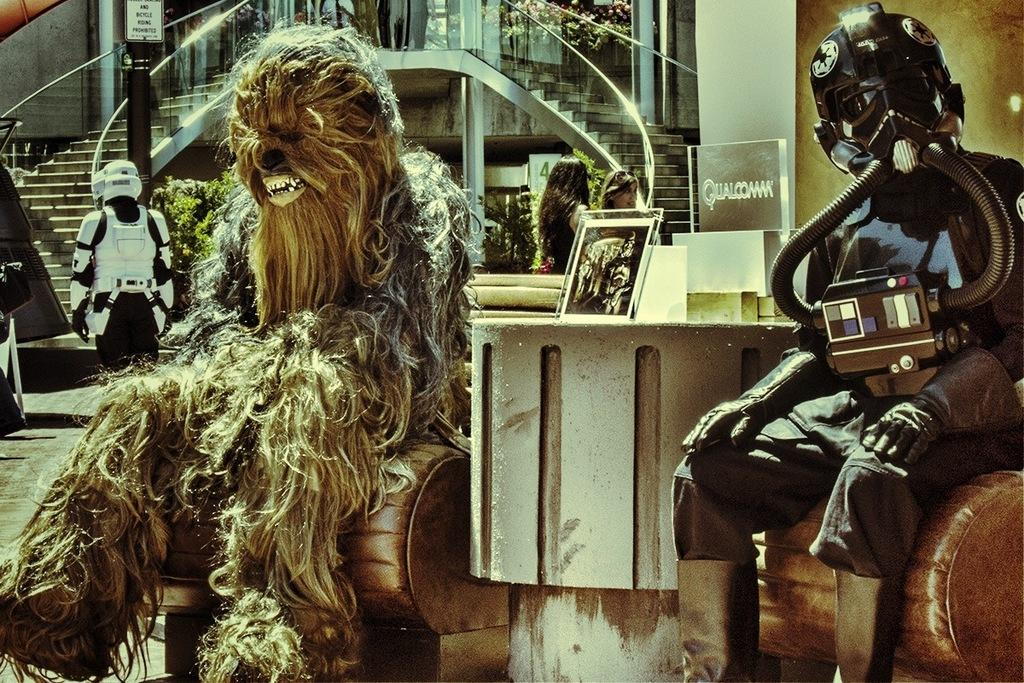What type of character is represented by the person in the image? There is a person in an animal costume in the image. What other subjects are present in the image? There are two robots, boards, plants, stairs, and two other persons in the image. Can you describe the setting of the image? The image features a person in an animal costume, two robots, boards, plants, and stairs, suggesting an outdoor or public area. How many toes can be seen on the sheep in the image? There is no sheep present in the image; the person is wearing an animal costume. What type of currency is visible in the image? There is no currency visible in the image. 